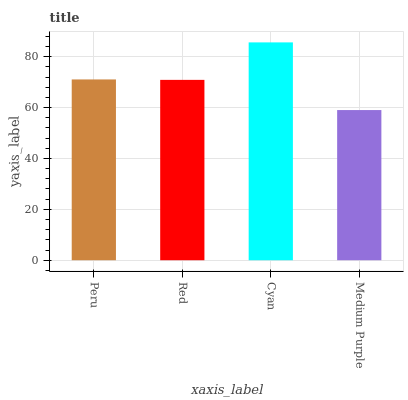Is Medium Purple the minimum?
Answer yes or no. Yes. Is Cyan the maximum?
Answer yes or no. Yes. Is Red the minimum?
Answer yes or no. No. Is Red the maximum?
Answer yes or no. No. Is Peru greater than Red?
Answer yes or no. Yes. Is Red less than Peru?
Answer yes or no. Yes. Is Red greater than Peru?
Answer yes or no. No. Is Peru less than Red?
Answer yes or no. No. Is Peru the high median?
Answer yes or no. Yes. Is Red the low median?
Answer yes or no. Yes. Is Medium Purple the high median?
Answer yes or no. No. Is Peru the low median?
Answer yes or no. No. 